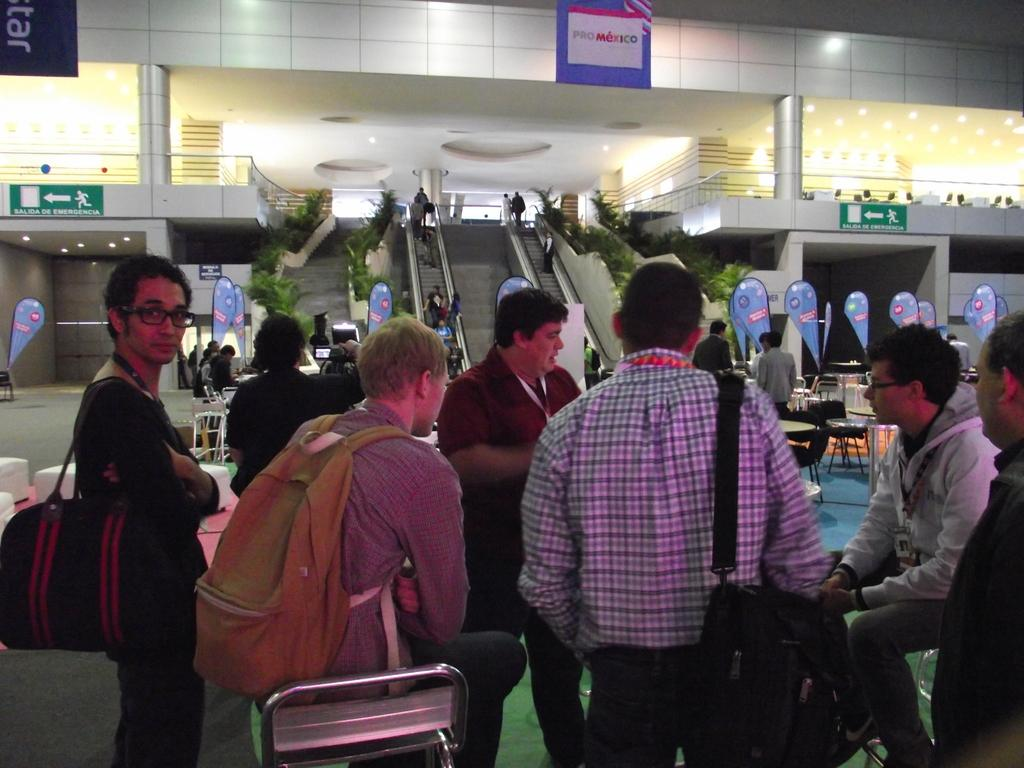What are the people in the image wearing on their bodies? Three people are wearing bags in the image. What are the positions of the people in the image? Two of the people are sitting. What can be seen in the distance in the image? There are escalators and chairs and tables visible in the distance. What type of vegetation is near the escalators? There are plants near the escalators. What is present to provide information or directions? There is a sign board in the image. How many pieces of paper are being smashed by the people in the image? There is no indication of paper or smashing in the image; the people are wearing bags and sitting. 